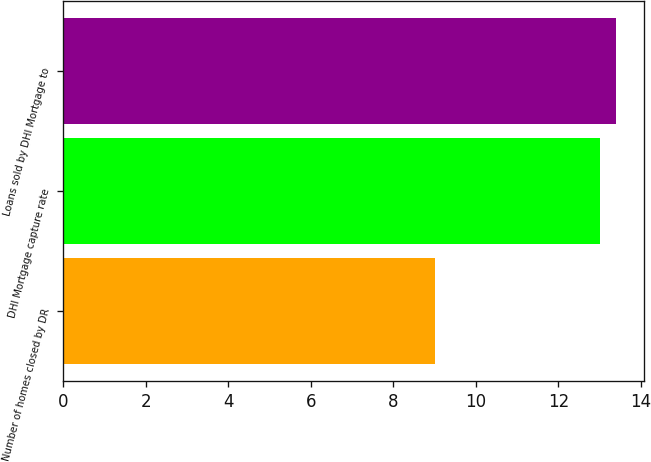<chart> <loc_0><loc_0><loc_500><loc_500><bar_chart><fcel>Number of homes closed by DR<fcel>DHI Mortgage capture rate<fcel>Loans sold by DHI Mortgage to<nl><fcel>9<fcel>13<fcel>13.4<nl></chart> 